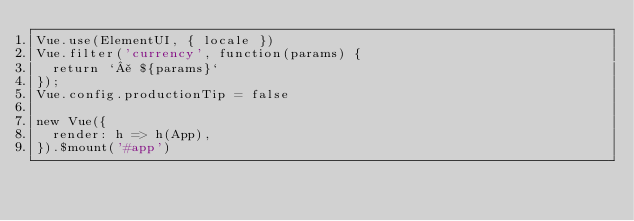<code> <loc_0><loc_0><loc_500><loc_500><_JavaScript_>Vue.use(ElementUI, { locale })
Vue.filter('currency', function(params) {
  return `¥ ${params}`
});
Vue.config.productionTip = false

new Vue({
  render: h => h(App),
}).$mount('#app')
</code> 